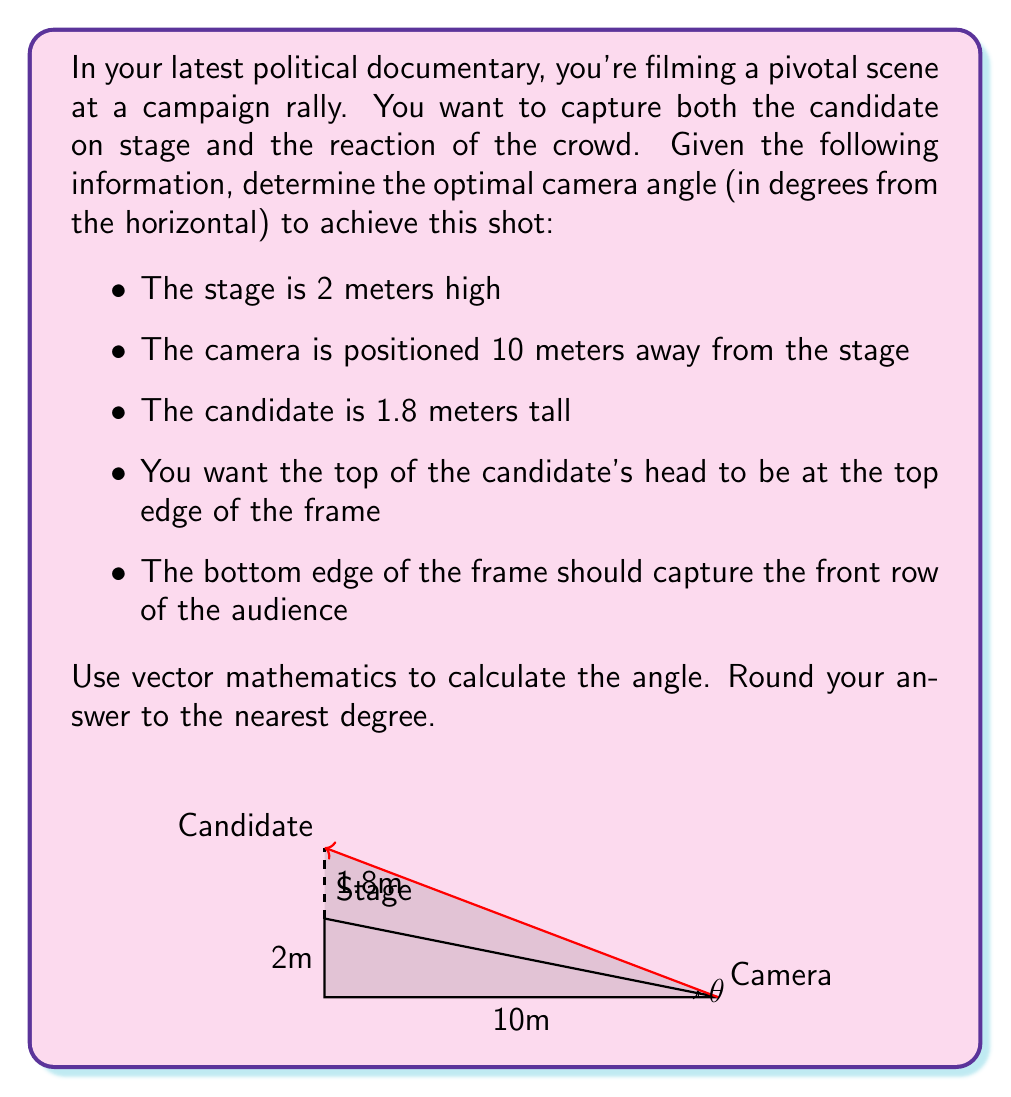Provide a solution to this math problem. Let's approach this step-by-step using vector mathematics:

1) First, we need to create vectors for our scenario:
   - Vector from camera to stage base: $\vec{v_1} = \langle 10, 2 \rangle$
   - Vector from camera to candidate's head: $\vec{v_2} = \langle 10, 3.8 \rangle$

2) The angle we're looking for is the one between $\vec{v_2}$ and the horizontal axis.

3) We can calculate this angle using the arctangent function:

   $$\theta = \arctan(\frac{y}{x})$$

   where $y$ is the vertical component and $x$ is the horizontal component of $\vec{v_2}$.

4) Plugging in our values:

   $$\theta = \arctan(\frac{3.8}{10})$$

5) Calculate:
   $$\theta = \arctan(0.38) \approx 0.3636 \text{ radians}$$

6) Convert to degrees:
   $$\theta \approx 0.3636 \times \frac{180}{\pi} \approx 20.83°$$

7) Rounding to the nearest degree:
   $$\theta \approx 21°$$

This angle will ensure that the top of the candidate's head is at the top of the frame while also capturing the front row of the audience at the bottom of the frame.
Answer: 21° 